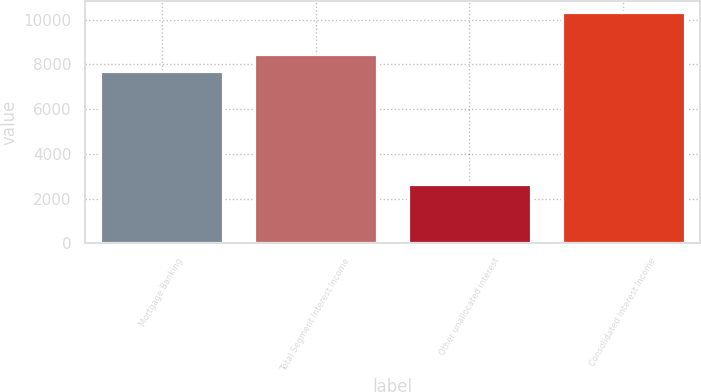Convert chart. <chart><loc_0><loc_0><loc_500><loc_500><bar_chart><fcel>Mortgage Banking<fcel>Total Segment Interest Income<fcel>Other unallocated interest<fcel>Consolidated Interest Income<nl><fcel>7704<fcel>8474.4<fcel>2639<fcel>10343<nl></chart> 